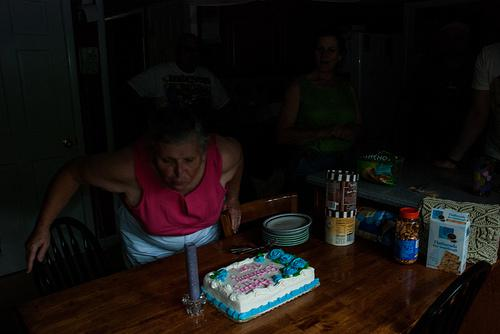Question: how many people are visible?
Choices:
A. Two.
B. Three.
C. Four.
D. Five.
Answer with the letter. Answer: C Question: why is there a cake?
Choices:
A. For a retirement.
B. For a birthday.
C. For a graduation.
D. For a baby shower.
Answer with the letter. Answer: B Question: what color is the woman's shirt?
Choices:
A. Pink.
B. Yellow.
C. Blue.
D. Orange.
Answer with the letter. Answer: A Question: what is on the cake?
Choices:
A. Balloons.
B. Flowers.
C. Trucks.
D. Dinosaurs.
Answer with the letter. Answer: B Question: what is the table made of?
Choices:
A. Wood.
B. Plastic.
C. Metal.
D. Glass.
Answer with the letter. Answer: A 